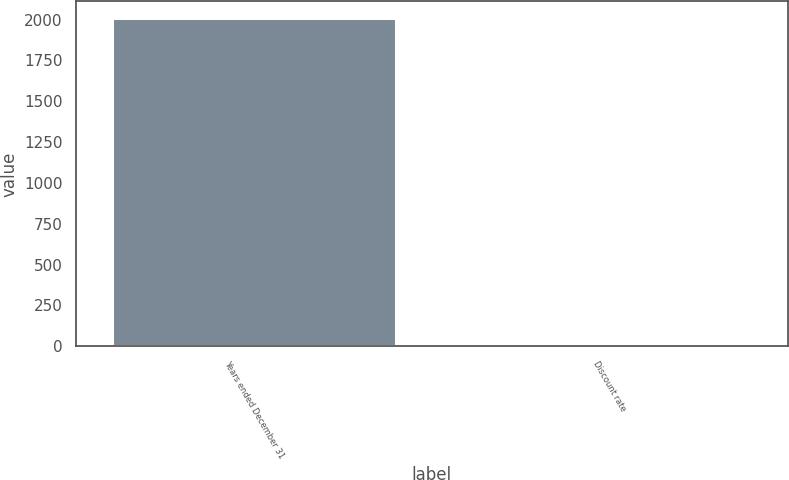Convert chart to OTSL. <chart><loc_0><loc_0><loc_500><loc_500><bar_chart><fcel>Years ended December 31<fcel>Discount rate<nl><fcel>2010<fcel>5.51<nl></chart> 